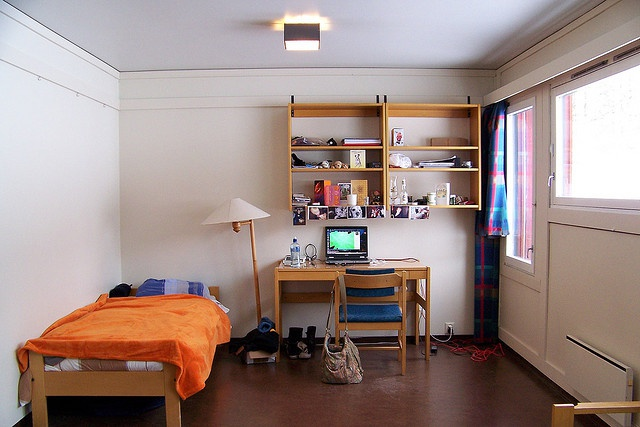Describe the objects in this image and their specific colors. I can see bed in darkgray, red, maroon, brown, and orange tones, chair in darkgray, black, brown, maroon, and navy tones, handbag in darkgray, black, gray, and maroon tones, laptop in darkgray, black, aquamarine, white, and gray tones, and tv in darkgray, black, aquamarine, white, and gray tones in this image. 